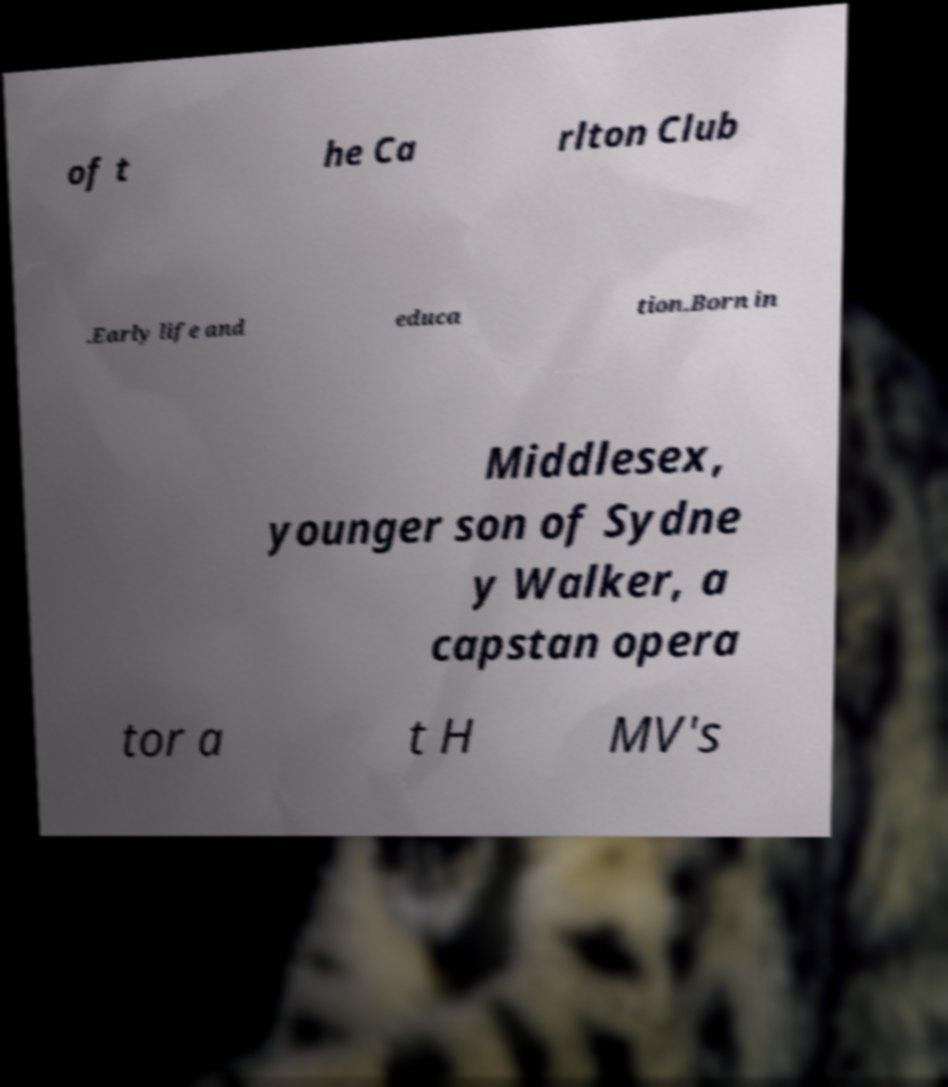Can you accurately transcribe the text from the provided image for me? of t he Ca rlton Club .Early life and educa tion.Born in Middlesex, younger son of Sydne y Walker, a capstan opera tor a t H MV's 